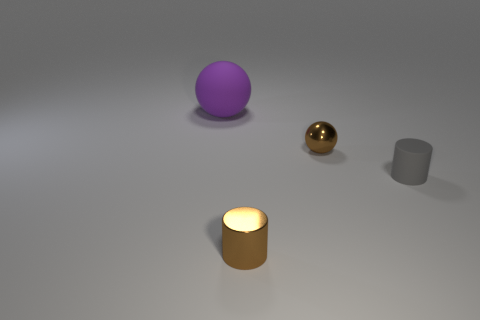Add 1 rubber cylinders. How many objects exist? 5 Subtract all green spheres. Subtract all red blocks. How many spheres are left? 2 Add 2 large purple things. How many large purple things are left? 3 Add 4 blue cylinders. How many blue cylinders exist? 4 Subtract 1 gray cylinders. How many objects are left? 3 Subtract all spheres. Subtract all rubber cylinders. How many objects are left? 1 